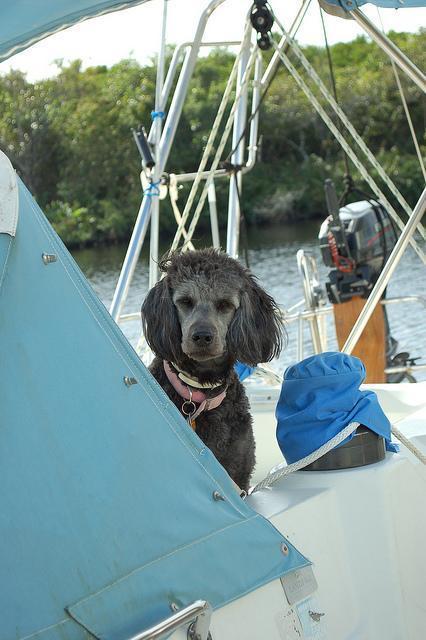How many zebras are eating grass in the image? there are zebras not eating grass too?
Give a very brief answer. 0. 